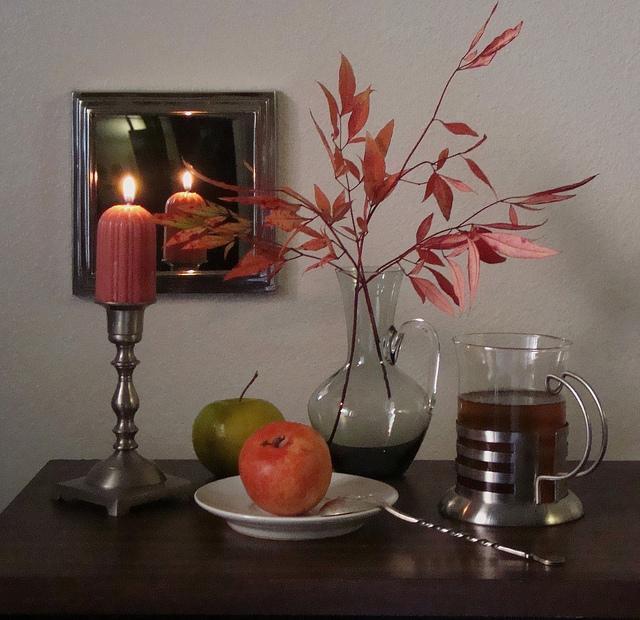How many apples are visible?
Give a very brief answer. 2. How many layers does this cake have?
Give a very brief answer. 0. 